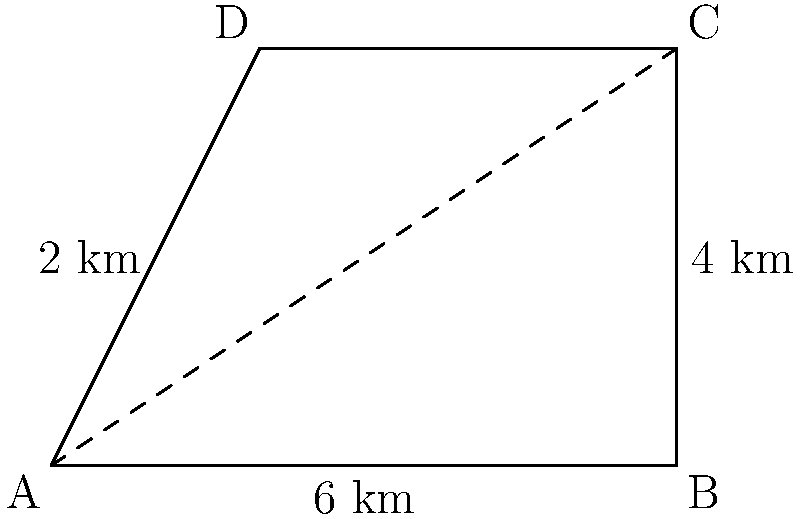A conservation biologist has been tracking the territory of a rare bird species. The territory is shaped like a quadrilateral ABCD, where AB = 6 km, BC = 4 km, and AD = 2 km. If AC is a diagonal of this quadrilateral, what is the area of the bird's territory in square kilometers? To solve this problem, we can follow these steps:

1) The quadrilateral ABCD can be divided into two triangles by the diagonal AC.

2) We can calculate the area of the quadrilateral by finding the sum of the areas of these two triangles.

3) For triangle ABC:
   - We know the base (AB) = 6 km and the height (BC) = 4 km
   - Area of triangle ABC = $\frac{1}{2} \times base \times height = \frac{1}{2} \times 6 \times 4 = 12$ sq km

4) For triangle ACD:
   - We know the base (AD) = 2 km, but we don't know the height
   - We can find the height by subtracting AD from BC: 4 - 2 = 2 km
   - Area of triangle ACD = $\frac{1}{2} \times base \times height = \frac{1}{2} \times 2 \times 2 = 2$ sq km

5) Total area of quadrilateral ABCD:
   $Area_{ABCD} = Area_{ABC} + Area_{ACD} = 12 + 2 = 14$ sq km

Therefore, the area of the bird's territory is 14 square kilometers.
Answer: 14 sq km 